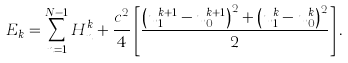<formula> <loc_0><loc_0><loc_500><loc_500>E _ { k } = \sum _ { n = 1 } ^ { N - 1 } H _ { n } ^ { k } + \frac { c ^ { 2 } } { 4 } \left [ \frac { \left ( u _ { 1 } ^ { k + 1 } - u _ { 0 } ^ { k + 1 } \right ) ^ { 2 } + \left ( u _ { 1 } ^ { k } - u _ { 0 } ^ { k } \right ) ^ { 2 } } { 2 } \right ] .</formula> 